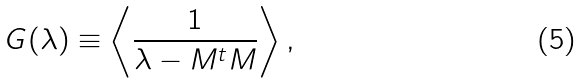<formula> <loc_0><loc_0><loc_500><loc_500>G ( \lambda ) \equiv \left < \frac { 1 } { \lambda - M ^ { t } M } \right > ,</formula> 